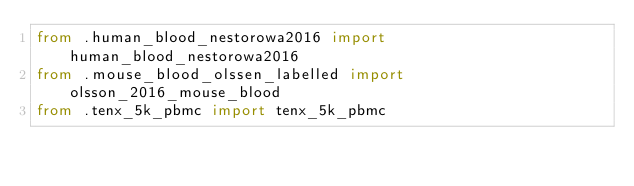Convert code to text. <code><loc_0><loc_0><loc_500><loc_500><_Python_>from .human_blood_nestorowa2016 import human_blood_nestorowa2016
from .mouse_blood_olssen_labelled import olsson_2016_mouse_blood
from .tenx_5k_pbmc import tenx_5k_pbmc
</code> 